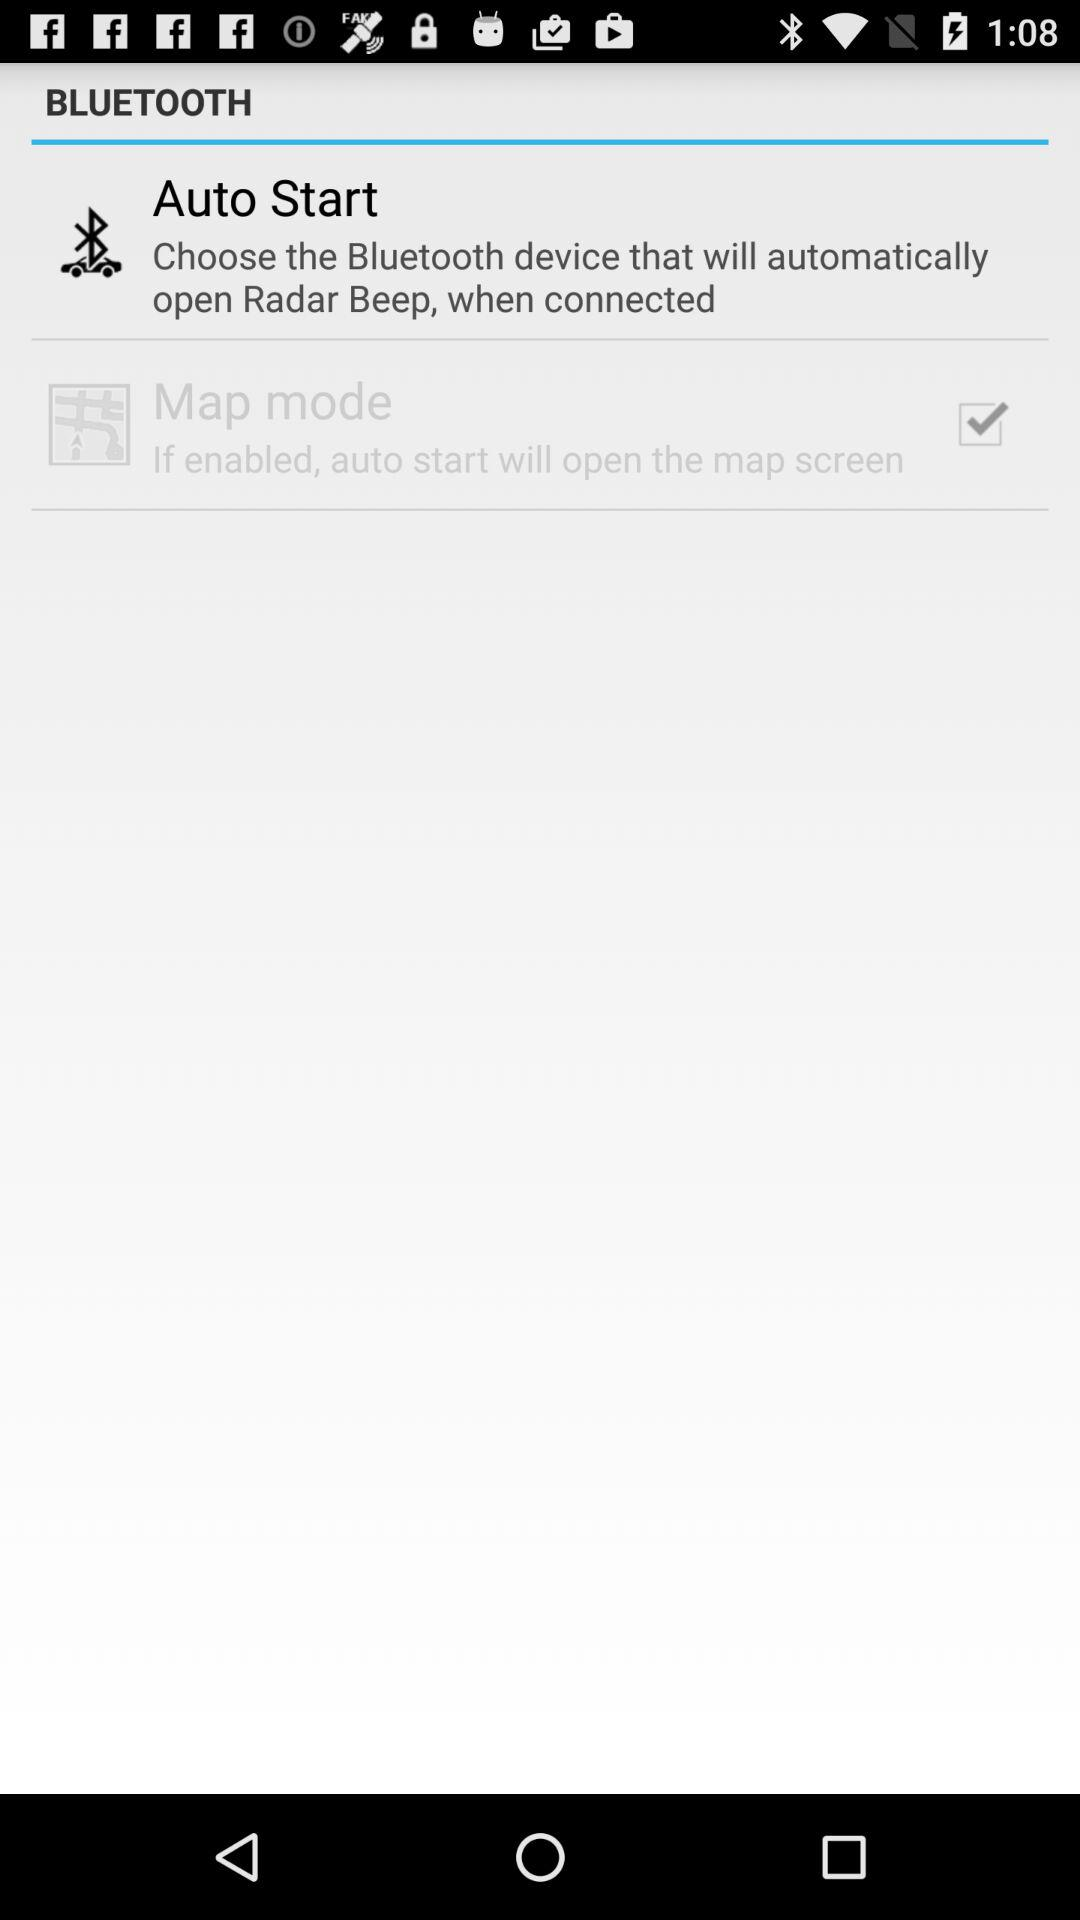What's the status of "Map mode"? The status of "Map mode" is "on". 